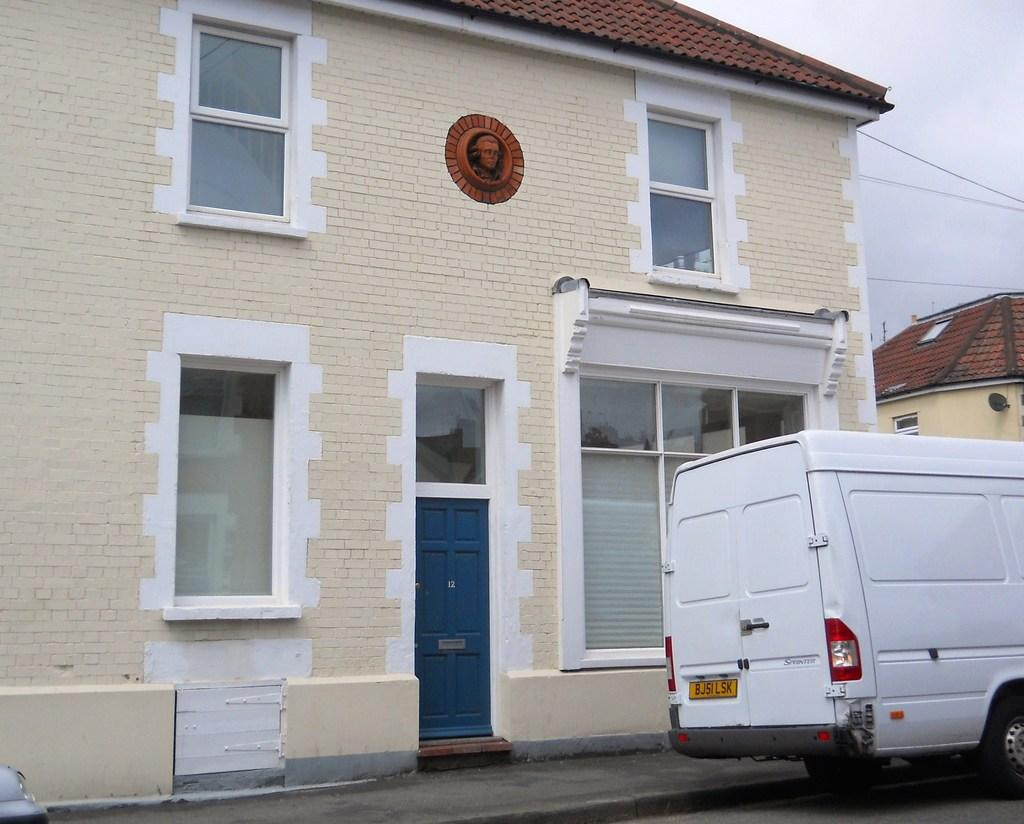What type of structure is in the image? There is a house in the image. What features can be seen on the house? The house has windows and a door. Is there any artwork or decoration on the house? Yes, there is a depiction of a person on the house. Are there any other houses visible in the image? Yes, there is another house to the right side of the image. What else can be seen in the image? There is a vehicle on the road in the image. What songs is the grandfather singing in the image? There is no grandfather or singing present in the image. 